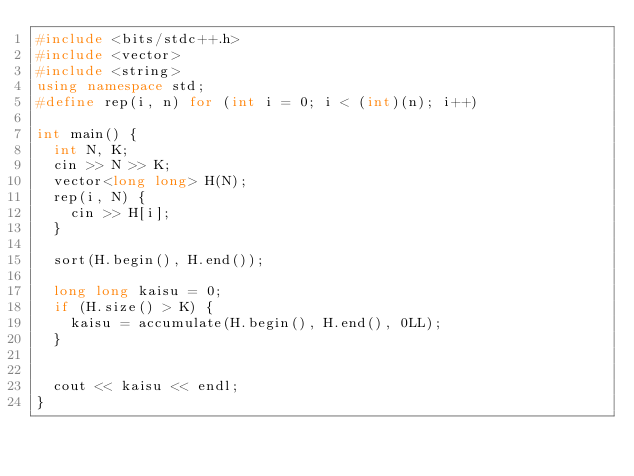Convert code to text. <code><loc_0><loc_0><loc_500><loc_500><_C++_>#include <bits/stdc++.h>
#include <vector>
#include <string>
using namespace std;
#define rep(i, n) for (int i = 0; i < (int)(n); i++)

int main() {
  int N, K;
  cin >> N >> K;
  vector<long long> H(N);
  rep(i, N) {
    cin >> H[i];
  }
  
  sort(H.begin(), H.end());
  
  long long kaisu = 0;
  if (H.size() > K) {
    kaisu = accumulate(H.begin(), H.end(), 0LL);
  } 
  
  
  cout << kaisu << endl;
}
  </code> 